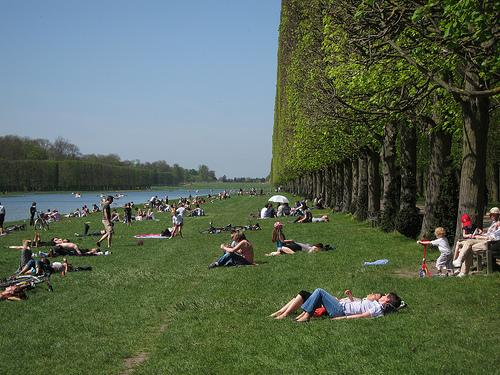Write a brief overview of the activities happening in the image. Children play on scooters while couples relax on grass and friends chat under a white umbrella; trees and a clear sky provide a pleasant backdrop. Create a brief, poetic description of the image. In nature's cradle, laughter flits on scooters' wheels, love rests on soft grass, friendships bloom under white shade, and green sentinels stand guard. Describe the atmosphere and the people within the image. Filled with joy and relaxation, the park is a perfect getaway for families and friends, with children enjoying their scooters and couples laying on the lush green grass under the canopy of the blue sky and tall trees. Write a concise summary of the main image elements and activities. A pleasant park with children on scooters, people relaxing on grass, a group under a white umbrella, lined trees, and clear sky above. Provide a casual description of the image as if telling a friend. You should've seen the park today! Kids were zipping around on scooters, couples were cuddled up on the grass, and a group of people was hanging out under this big white umbrella. List the most prominent elements and actions taking place in the image. Children riding scooters, couples lying on grass, group sitting under a white umbrella, trees lined up, clear sky, and people near a river. Report the different activities and elements in the image as if you are a news reporter. Live from the park today, we see children happily riding scooters, couples sharing romantic moments on the grass, and a group of people enjoying conversation under a white umbrella, all amidst a picturesque background of trees and a clear blue sky. Write a description of the image as if it is a scene from a novel. In the sunlit park, the laughter of children echoed as they rode their scooters through the green, grassy landscape, while couples lay side by side, embracing the warmth of the day, and friends huddled beneath a white umbrella to share tales and smiles. What can be observed about the people and the environment in the image? People are enjoying outdoor activities, wearing casual clothing, surrounded by green trees and grass, and a clear sky above them. Paint a mental picture of the scene taking place in the image. A vibrant scene at the park with people enjoying various activities, such as kids riding scooters, couples lying on the grass, and a small group sitting under a white umbrella near a row of trees. 